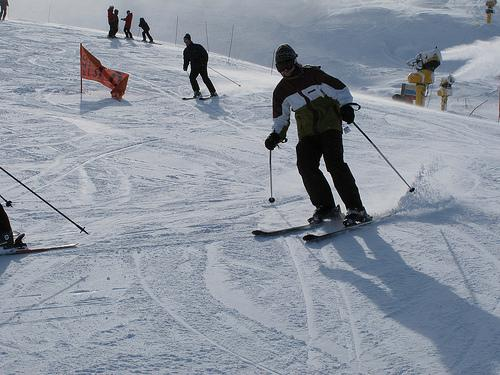Question: where is this scene?
Choices:
A. A mountain top.
B. A ski slope.
C. A field.
D. A valley.
Answer with the letter. Answer: B Question: what is all over the ground?
Choices:
A. Rain.
B. Snow.
C. Hail.
D. Ice.
Answer with the letter. Answer: B Question: what are the people doing?
Choices:
A. Surfing.
B. Running.
C. Skiing.
D. Riding.
Answer with the letter. Answer: C Question: how many skiiers can you see?
Choices:
A. Seven.
B. Six.
C. Five.
D. Three.
Answer with the letter. Answer: A Question: what is on the near skier's face?
Choices:
A. Ski mask.
B. Scarf.
C. Goggles.
D. Sunscreen.
Answer with the letter. Answer: C Question: when was this photo taken?
Choices:
A. In the evening.
B. In the morning.
C. During the day.
D. In the afternoon.
Answer with the letter. Answer: C Question: what are the skiers holding?
Choices:
A. Skis.
B. Masks.
C. Hats.
D. Ski poles.
Answer with the letter. Answer: D 